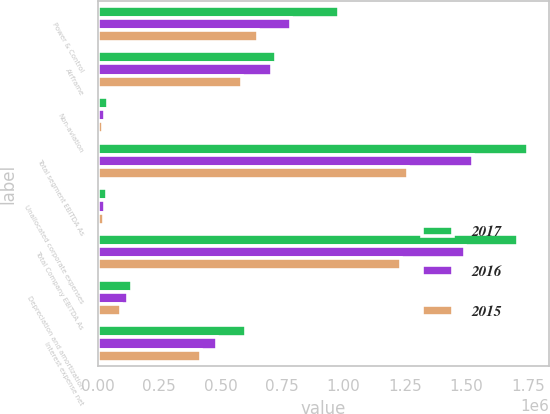Convert chart to OTSL. <chart><loc_0><loc_0><loc_500><loc_500><stacked_bar_chart><ecel><fcel>Power & Control<fcel>Airframe<fcel>Non-aviation<fcel>Total segment EBITDA As<fcel>Unallocated corporate expenses<fcel>Total Company EBITDA As<fcel>Depreciation and amortization<fcel>Interest expense net<nl><fcel>2017<fcel>981041<fcel>726619<fcel>41460<fcel>1.74912e+06<fcel>38557<fcel>1.71056e+06<fcel>141025<fcel>602589<nl><fcel>2016<fcel>787418<fcel>709858<fcel>28228<fcel>1.5255e+06<fcel>30308<fcel>1.4952e+06<fcel>121670<fcel>483850<nl><fcel>2015<fcel>653050<fcel>585472<fcel>22406<fcel>1.26093e+06<fcel>27274<fcel>1.23365e+06<fcel>93663<fcel>418785<nl></chart> 